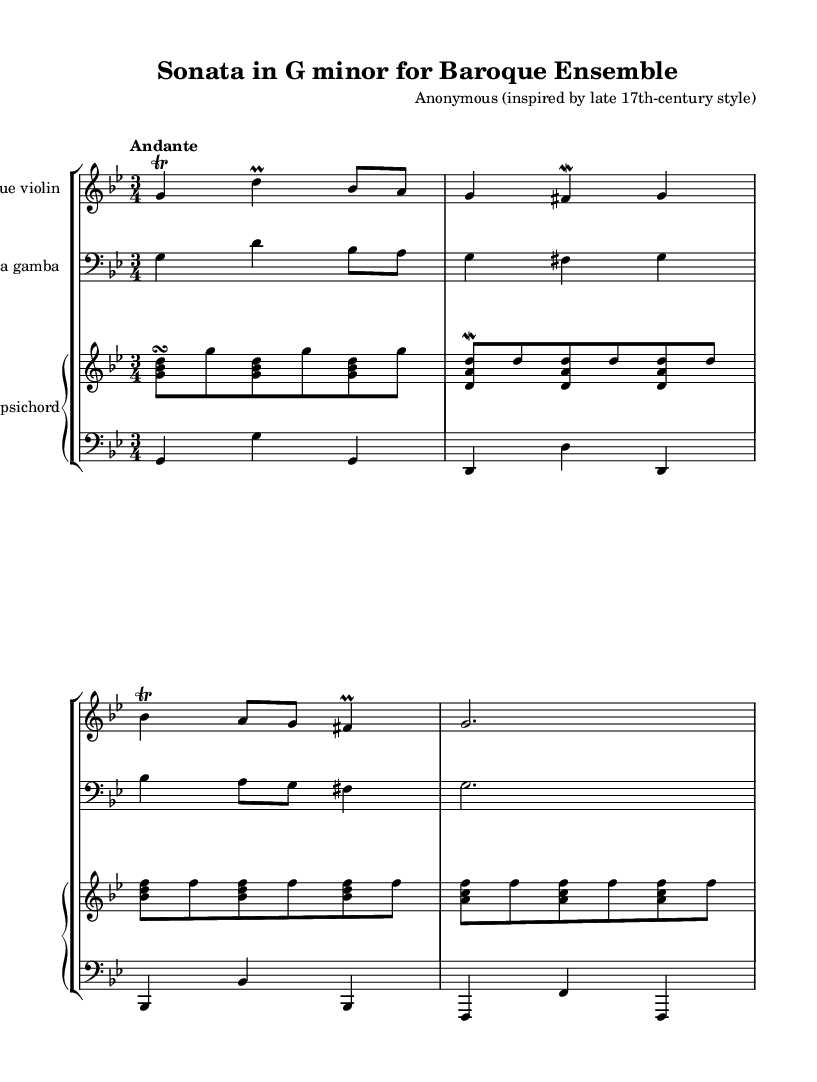What is the key signature of this music? The key signature is indicated at the beginning of the score and shows two flats, which corresponds to the key of G minor.
Answer: G minor What is the time signature of this music? The time signature is located at the start of the score, which is 3/4, indicating three beats per measure.
Answer: 3/4 What tempo marking is given for this piece? The tempo is indicated at the beginning of the score as "Andante," which suggests a moderate pace.
Answer: Andante How many instruments are specified in this score? The score lists three individual Staves, which represent four instruments: the Baroque violin, viola da gamba, and harpsichord (with the harpsichord split into right and left hands).
Answer: Three What is the dynamic marking indicated in the violin part? The violin part does not have specific dynamic markings; however, performance practice suggests that Baroque music often uses a mix of subtle dynamics, typically using an expressive touch.
Answer: None (implied expressiveness) What is the melodic contour of the first phrase in the violin part? The first phrase begins with a trill on G, then descends and then ascends again with a continuation of notes that suggest a fluid motion typical of Baroque styles.
Answer: Ascending and descending How is the harpsichord typically utilized in this piece? The harpsichord plays both the harmonic foundation and embellishments, characterized by its strummed sound that complements the melodic lines, typical of Baroque chamber music.
Answer: Harmonic foundation and embellishments 